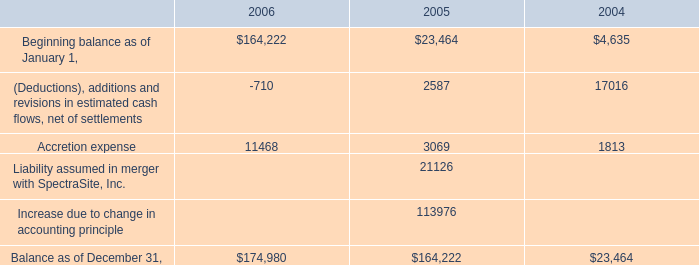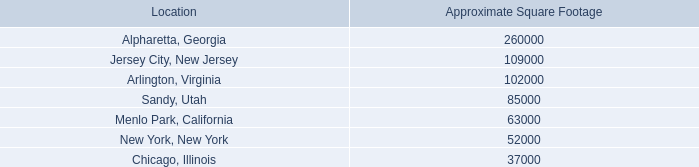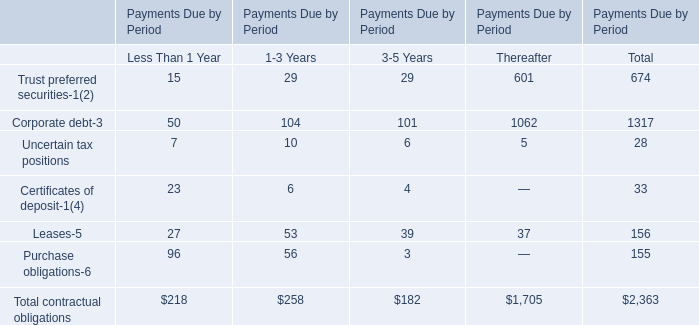what's the total amount of New York, New York of Approximate Square Footage, and Liability assumed in merger with SpectraSite, Inc. of 2005 ? 
Computations: (52000.0 + 21126.0)
Answer: 73126.0. 